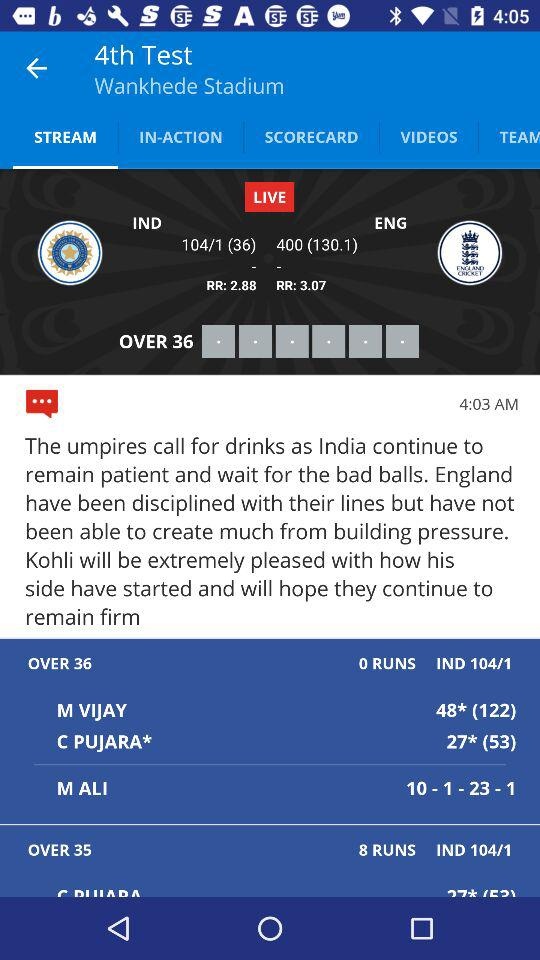Which bowler has taken the wicket for England, and what are the bowler's current figures? The bowler for England who has taken the wicket is M Ali. His current bowling figures are 10 overs, 1 maiden, 23 runs, and 1 wicket. 